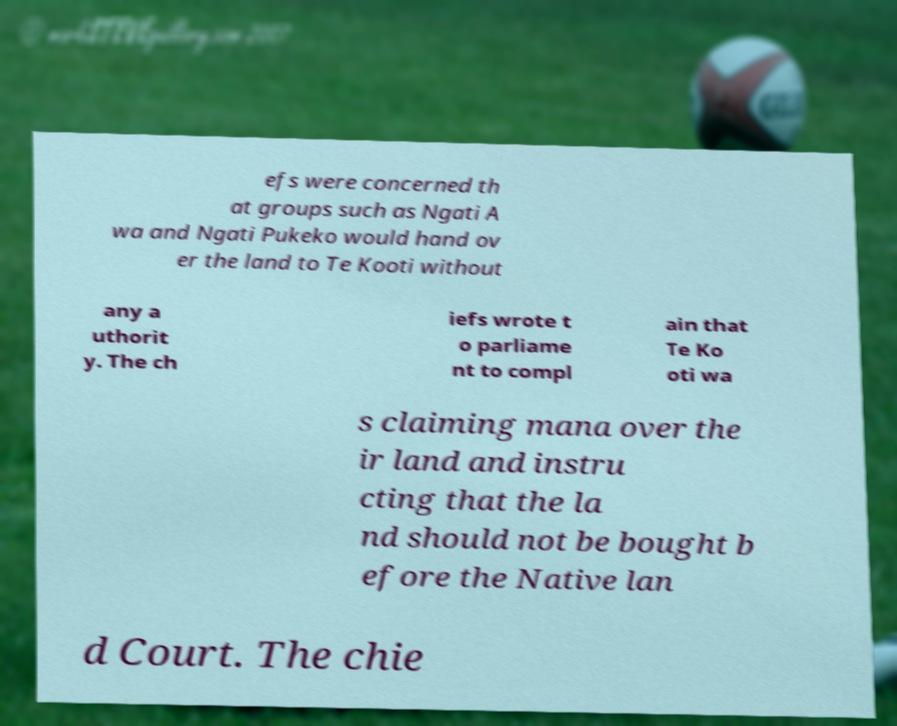Please identify and transcribe the text found in this image. efs were concerned th at groups such as Ngati A wa and Ngati Pukeko would hand ov er the land to Te Kooti without any a uthorit y. The ch iefs wrote t o parliame nt to compl ain that Te Ko oti wa s claiming mana over the ir land and instru cting that the la nd should not be bought b efore the Native lan d Court. The chie 